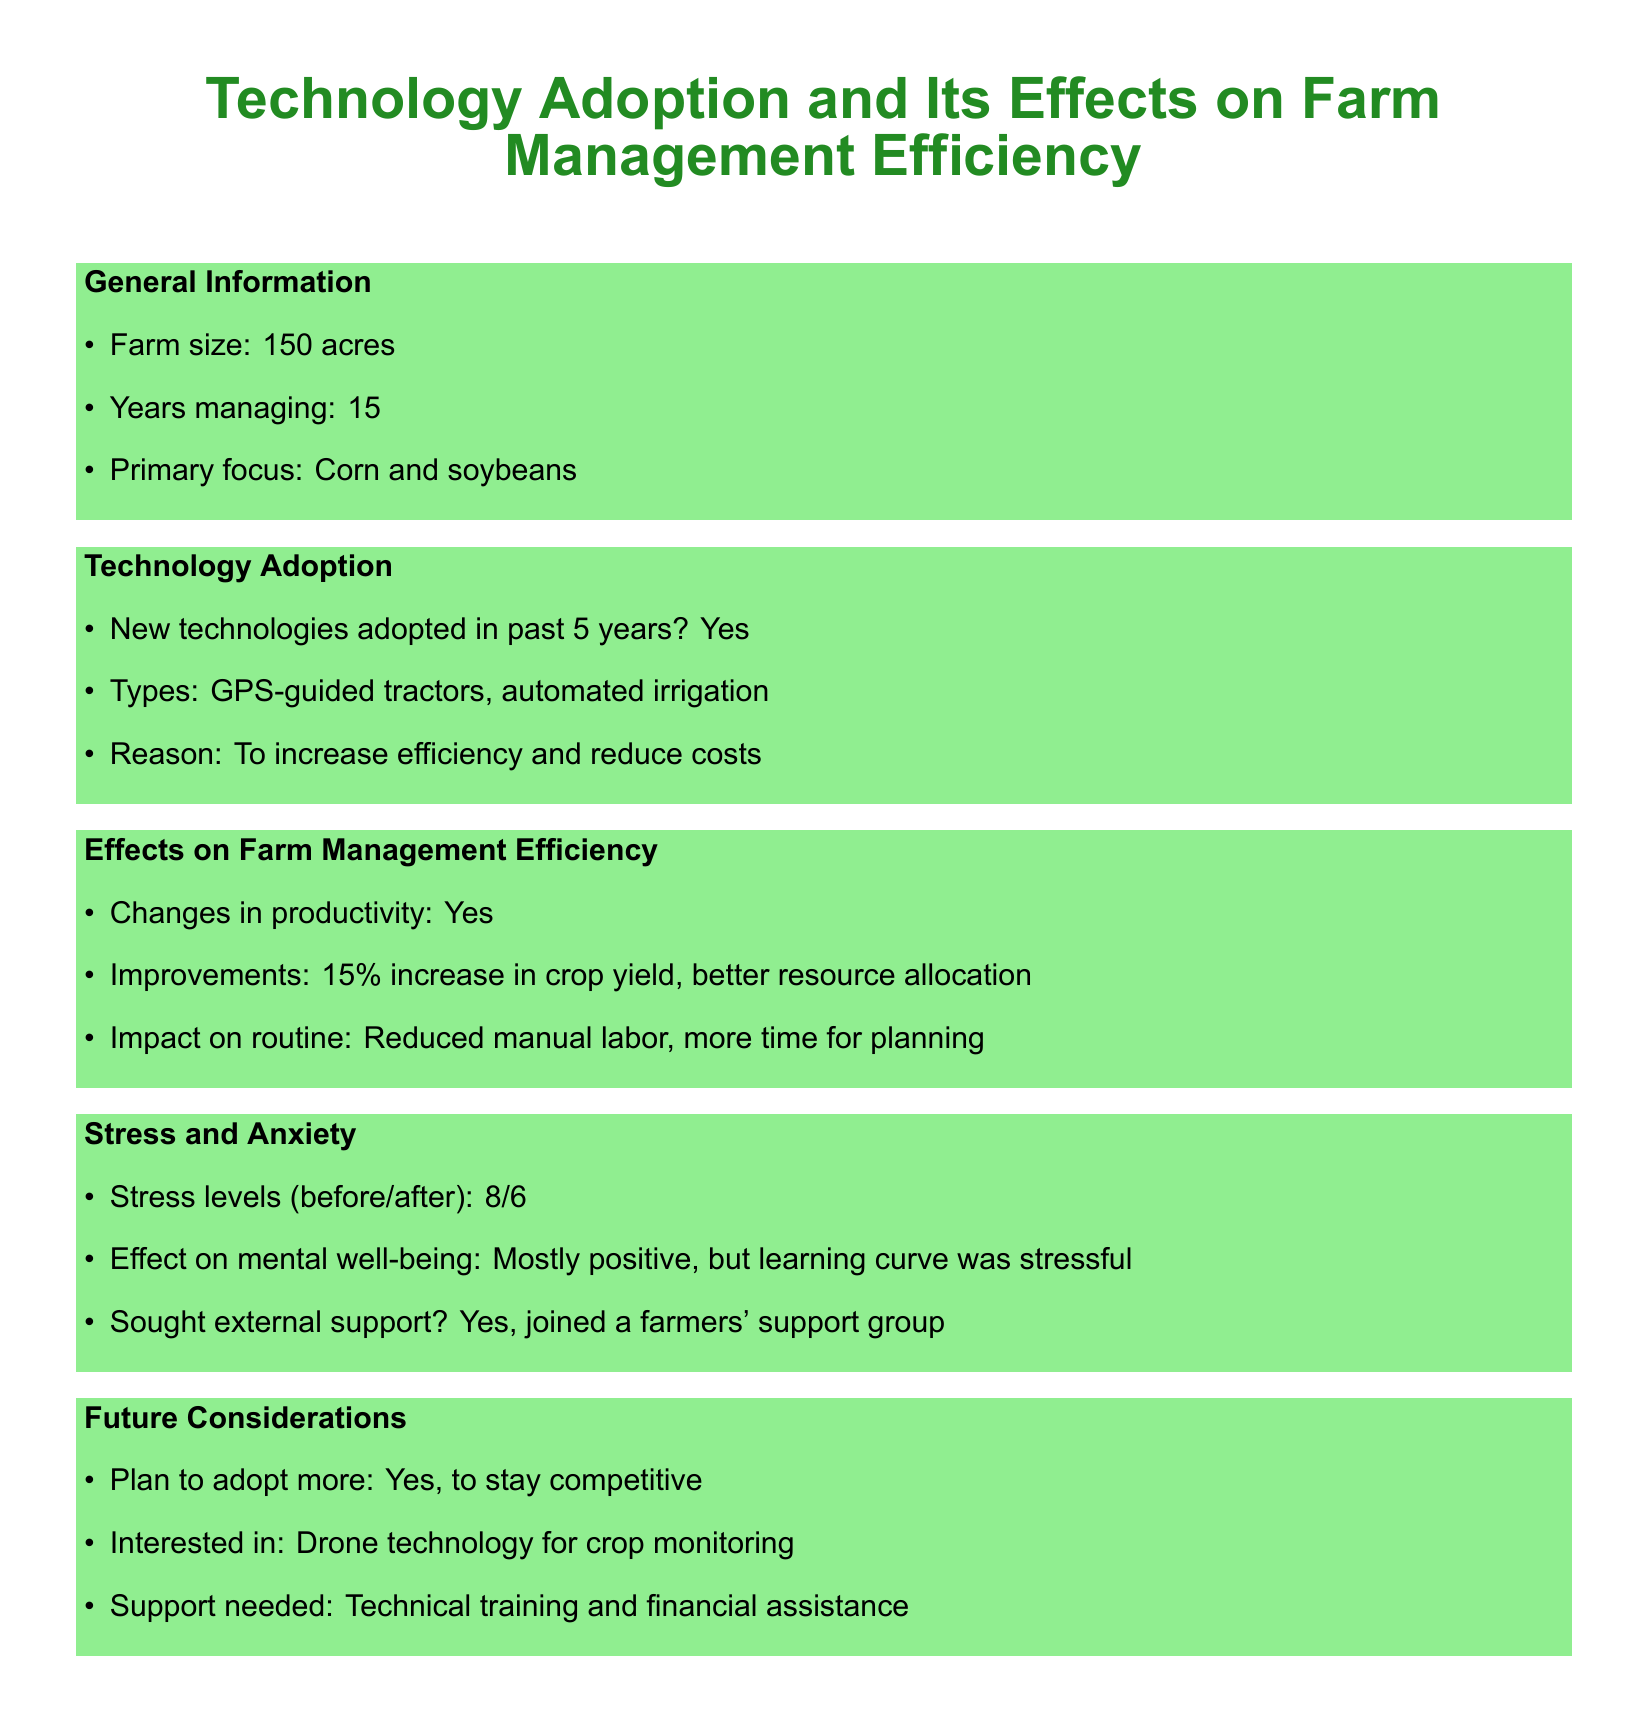What is the farm size? The farm size is listed in the general information section of the document.
Answer: 150 acres How many years has the farmer been managing the farm? The document states the number of years managing the farm in the general information section.
Answer: 15 What technologies were adopted in the past 5 years? The document specifies the types of technologies adopted under the technology adoption section.
Answer: GPS-guided tractors, automated irrigation What was the increase in crop yield after adopting new technologies? The document mentions the improvements in productivity as a result of technology adoption.
Answer: 15% What was the farmer's stress level before adopting new technologies? The document provides the farmer's stress levels before and after the adoption of new technologies.
Answer: 8 What support did the farmer seek for managing stress? The document outlines the external support the farmer sought due to stress.
Answer: Joined a farmers' support group What future technology does the farmer plan to adopt? The document indicates the farmer's interest in future technologies in the future considerations section.
Answer: Drone technology for crop monitoring What is the farmer's reason for adopting new technologies? The document explains the rationale behind adopting new technologies in the technology adoption section.
Answer: To increase efficiency and reduce costs How does stress level change after adopting new technologies? The document describes the change in stress level after the adoption of new technologies.
Answer: 6 